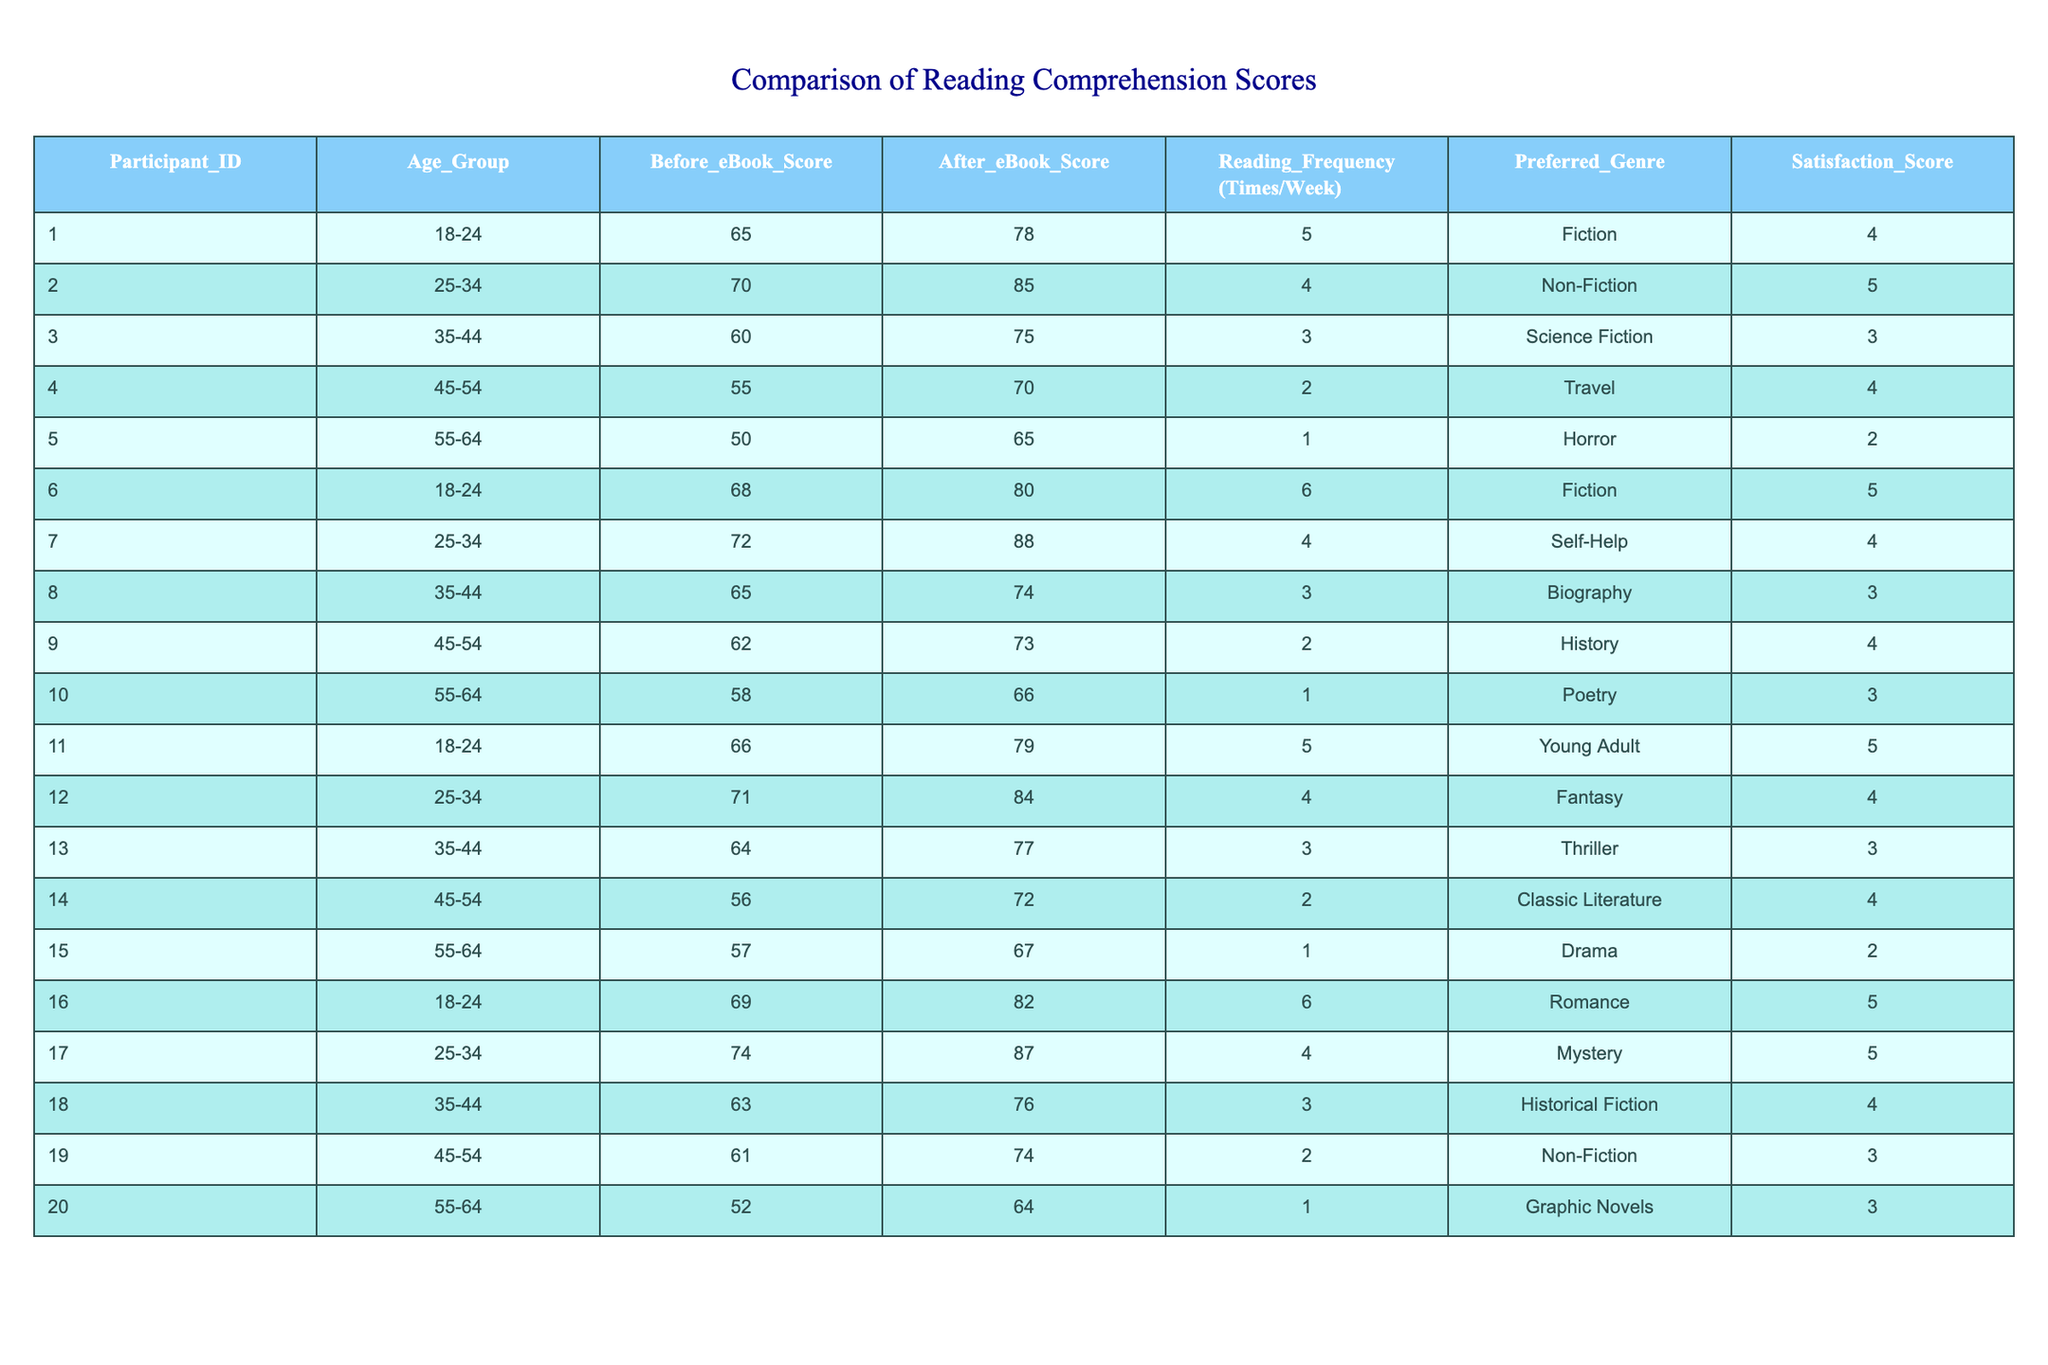What is the highest After eBook Score recorded in the table? Looking at the "After eBook Score" column, the highest score listed is 88, which belongs to Participant 7 in the 25-34 age group.
Answer: 88 What is the lowest Before eBook Score in the table? The "Before eBook Score" column shows that the lowest score is 50, which belongs to Participant 5 in the 55-64 age group.
Answer: 50 What is the average Reading Frequency (Times/Week) across all participants? To calculate the average, sum all the weekly readings (5 + 4 + 3 + 2 + 1 + 6 + 4 + 3 + 2 + 1 + 5 + 4 + 3 + 2 + 1 + 6 + 4 + 3 + 2 + 1 = 59) and divide by the number of participants (20): 59/20 = 2.95.
Answer: 2.95 Did any participant report a Satisfaction Score of 5? Yes, multiple participants reported a Satisfaction Score of 5, specifically Participants 2, 6, 11, 12, 16, and 17.
Answer: Yes What is the average increase in After eBook Score compared to Before eBook Score? The increase for each participant is calculated (13, 15, 15, 15, 15, 12, 16, 9, 12, 8, 13, 13, 13, 16, 10, 13, 13, 13, 13, 12) giving a total of 266. Dividing this by the number of participants (20), the average increase is 266/20 = 13.3.
Answer: 13.3 Which age group had the highest Before eBook Score on average? Calculating the average for each age group: 18-24 = (65 + 68 + 66 + 69)/4 = 67, 25-34 = (70 + 72 + 71 + 74)/4 = 71.75, 35-44 = (60 + 65 + 64 + 63)/4 = 62. The 25-34 age group has the highest average score of 71.75.
Answer: 25-34 Is there a participant who preferred Horror and had a satisfaction score of 5? No, the participant who preferred Horror (Participant 5) had a satisfaction score of 2.
Answer: No What is the total number of participants who belong to the age group 55-64? By counting the entries for the 55-64 age group (participants 5, 10, 15, and 20), there are 4 participants.
Answer: 4 By how much did Participant 2's score improve? Participant 2's score improved from 70 to 85, resulting in an increase of 85 - 70 = 15.
Answer: 15 Which genre had the most participants preferring it? The genre 'Fiction' is preferred by 4 participants (1, 6, 11, and 16), which is more than any other genre.
Answer: Fiction Was there any participant in the age group 45-54 who reported a Satisfaction Score of 3? Yes, Participant 19, who belongs to the 45-54 age group, reported a Satisfaction Score of 3.
Answer: Yes 